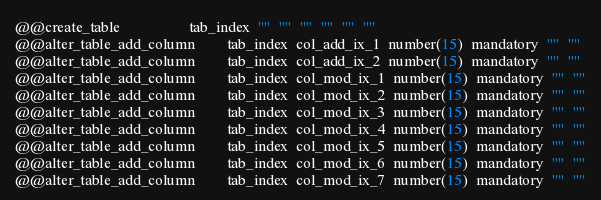Convert code to text. <code><loc_0><loc_0><loc_500><loc_500><_SQL_>
@@create_table                  tab_index  ""  ""  ""  ""  ""  ""
@@alter_table_add_column        tab_index  col_add_ix_1  number(15)  mandatory  ""  ""
@@alter_table_add_column        tab_index  col_add_ix_2  number(15)  mandatory  ""  ""
@@alter_table_add_column        tab_index  col_mod_ix_1  number(15)  mandatory  ""  ""
@@alter_table_add_column        tab_index  col_mod_ix_2  number(15)  mandatory  ""  ""
@@alter_table_add_column        tab_index  col_mod_ix_3  number(15)  mandatory  ""  ""
@@alter_table_add_column        tab_index  col_mod_ix_4  number(15)  mandatory  ""  ""
@@alter_table_add_column        tab_index  col_mod_ix_5  number(15)  mandatory  ""  ""
@@alter_table_add_column        tab_index  col_mod_ix_6  number(15)  mandatory  ""  ""
@@alter_table_add_column        tab_index  col_mod_ix_7  number(15)  mandatory  ""  ""</code> 